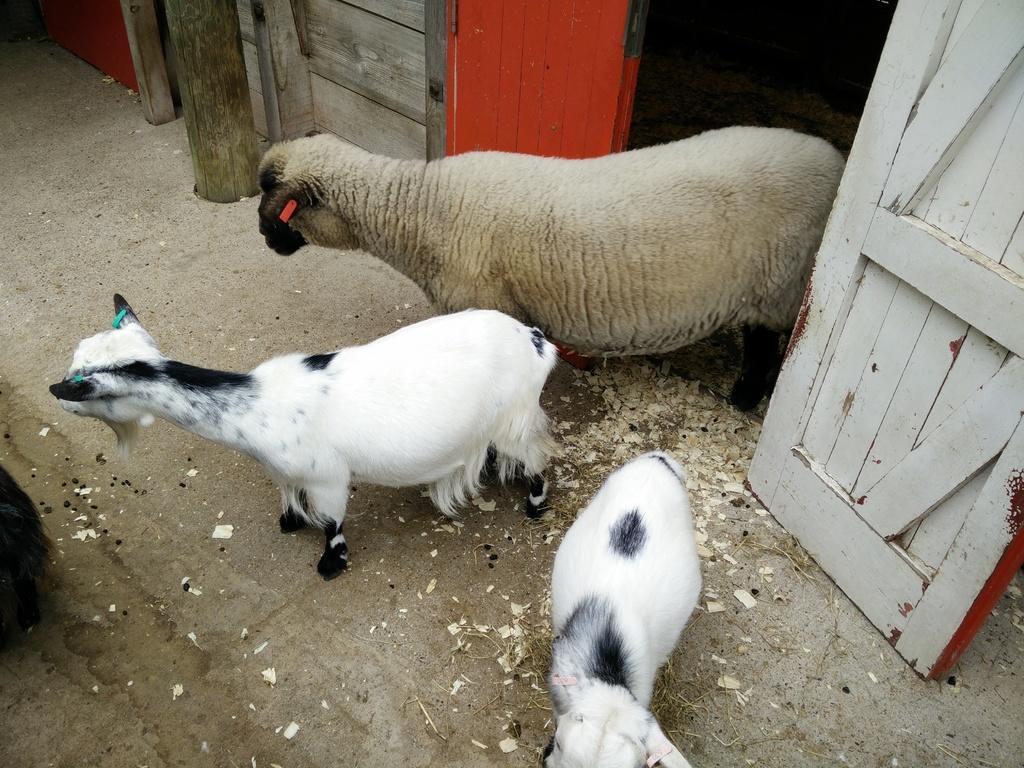Can you describe this image briefly? In this picture there is a sheep and two lambs in the image and there is a wooden house and a bamboo at the top side of the image. 